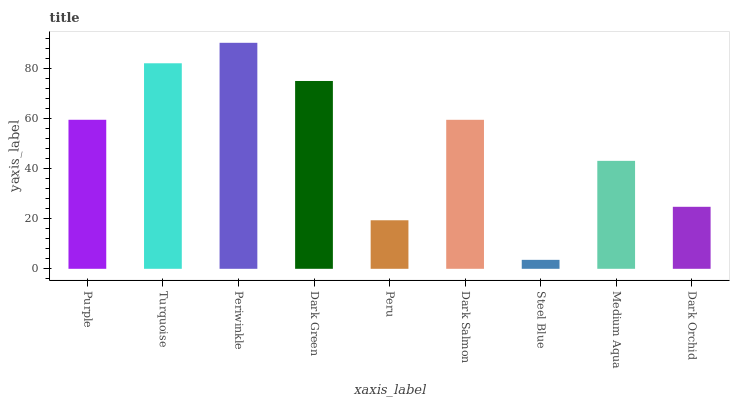Is Turquoise the minimum?
Answer yes or no. No. Is Turquoise the maximum?
Answer yes or no. No. Is Turquoise greater than Purple?
Answer yes or no. Yes. Is Purple less than Turquoise?
Answer yes or no. Yes. Is Purple greater than Turquoise?
Answer yes or no. No. Is Turquoise less than Purple?
Answer yes or no. No. Is Dark Salmon the high median?
Answer yes or no. Yes. Is Dark Salmon the low median?
Answer yes or no. Yes. Is Periwinkle the high median?
Answer yes or no. No. Is Periwinkle the low median?
Answer yes or no. No. 